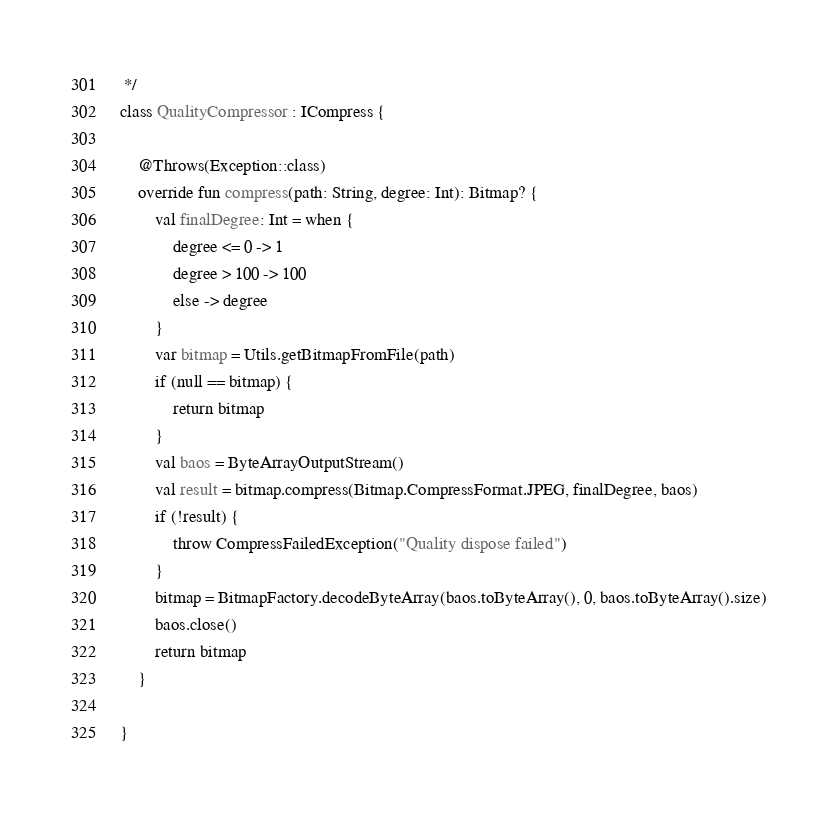<code> <loc_0><loc_0><loc_500><loc_500><_Kotlin_> */
class QualityCompressor : ICompress {

    @Throws(Exception::class)
    override fun compress(path: String, degree: Int): Bitmap? {
        val finalDegree: Int = when {
            degree <= 0 -> 1
            degree > 100 -> 100
            else -> degree
        }
        var bitmap = Utils.getBitmapFromFile(path)
        if (null == bitmap) {
            return bitmap
        }
        val baos = ByteArrayOutputStream()
        val result = bitmap.compress(Bitmap.CompressFormat.JPEG, finalDegree, baos)
        if (!result) {
            throw CompressFailedException("Quality dispose failed")
        }
        bitmap = BitmapFactory.decodeByteArray(baos.toByteArray(), 0, baos.toByteArray().size)
        baos.close()
        return bitmap
    }

}</code> 